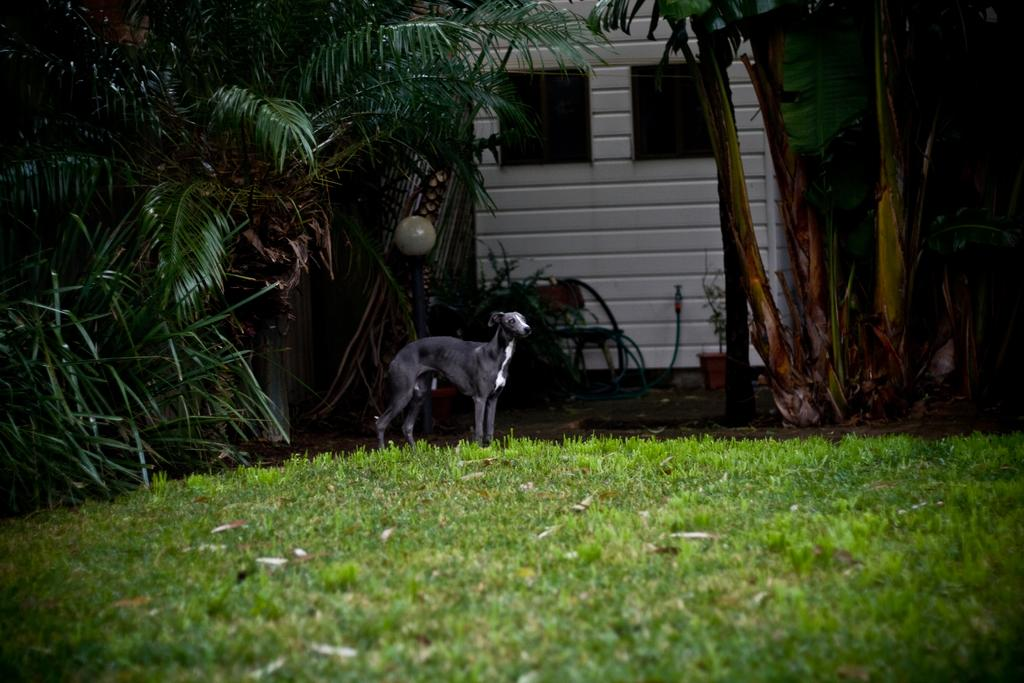What is the main subject of the image? There is a dog standing in the middle of the image. What is the dog standing on? The dog is on the grass. What can be seen on the left side of the image? There are trees on the left side of the image. What type of structure is visible in the image? There is a house in the image. What type of invention can be seen in the dog's paw in the image? There is no invention present in the dog's paw in the image. How many leaves are on the trees in the image? The provided facts do not mention the number of leaves on the trees, so it cannot be determined from the image. 